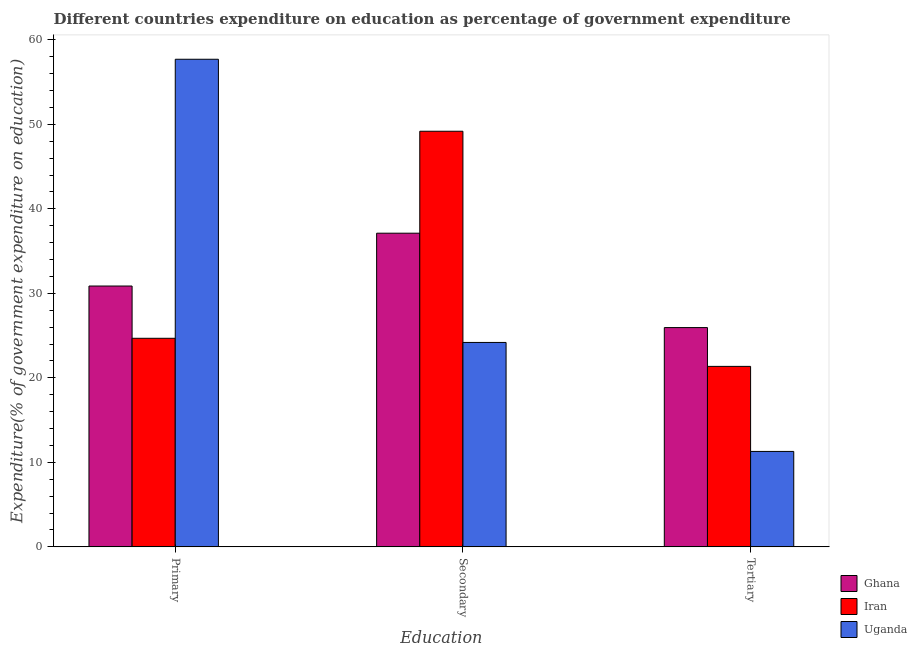How many different coloured bars are there?
Give a very brief answer. 3. How many bars are there on the 1st tick from the left?
Offer a terse response. 3. How many bars are there on the 1st tick from the right?
Your response must be concise. 3. What is the label of the 2nd group of bars from the left?
Make the answer very short. Secondary. What is the expenditure on primary education in Ghana?
Give a very brief answer. 30.87. Across all countries, what is the maximum expenditure on primary education?
Your response must be concise. 57.7. Across all countries, what is the minimum expenditure on tertiary education?
Provide a short and direct response. 11.29. In which country was the expenditure on primary education maximum?
Offer a terse response. Uganda. In which country was the expenditure on secondary education minimum?
Ensure brevity in your answer.  Uganda. What is the total expenditure on secondary education in the graph?
Offer a very short reply. 110.49. What is the difference between the expenditure on primary education in Ghana and that in Iran?
Offer a very short reply. 6.19. What is the difference between the expenditure on secondary education in Iran and the expenditure on tertiary education in Uganda?
Keep it short and to the point. 37.89. What is the average expenditure on primary education per country?
Your answer should be very brief. 37.75. What is the difference between the expenditure on tertiary education and expenditure on secondary education in Uganda?
Ensure brevity in your answer.  -12.9. What is the ratio of the expenditure on tertiary education in Ghana to that in Iran?
Offer a terse response. 1.21. Is the difference between the expenditure on tertiary education in Iran and Ghana greater than the difference between the expenditure on primary education in Iran and Ghana?
Your response must be concise. Yes. What is the difference between the highest and the second highest expenditure on tertiary education?
Provide a short and direct response. 4.59. What is the difference between the highest and the lowest expenditure on secondary education?
Keep it short and to the point. 24.99. In how many countries, is the expenditure on tertiary education greater than the average expenditure on tertiary education taken over all countries?
Keep it short and to the point. 2. Is the sum of the expenditure on primary education in Ghana and Uganda greater than the maximum expenditure on secondary education across all countries?
Your response must be concise. Yes. What does the 2nd bar from the left in Primary represents?
Offer a terse response. Iran. What does the 1st bar from the right in Secondary represents?
Provide a short and direct response. Uganda. Is it the case that in every country, the sum of the expenditure on primary education and expenditure on secondary education is greater than the expenditure on tertiary education?
Your response must be concise. Yes. How many bars are there?
Give a very brief answer. 9. Are all the bars in the graph horizontal?
Offer a very short reply. No. What is the difference between two consecutive major ticks on the Y-axis?
Provide a short and direct response. 10. Does the graph contain any zero values?
Offer a very short reply. No. Does the graph contain grids?
Offer a very short reply. No. How are the legend labels stacked?
Offer a terse response. Vertical. What is the title of the graph?
Provide a short and direct response. Different countries expenditure on education as percentage of government expenditure. Does "Europe(all income levels)" appear as one of the legend labels in the graph?
Ensure brevity in your answer.  No. What is the label or title of the X-axis?
Give a very brief answer. Education. What is the label or title of the Y-axis?
Offer a terse response. Expenditure(% of government expenditure on education). What is the Expenditure(% of government expenditure on education) in Ghana in Primary?
Make the answer very short. 30.87. What is the Expenditure(% of government expenditure on education) in Iran in Primary?
Your answer should be very brief. 24.68. What is the Expenditure(% of government expenditure on education) in Uganda in Primary?
Provide a succinct answer. 57.7. What is the Expenditure(% of government expenditure on education) of Ghana in Secondary?
Offer a terse response. 37.12. What is the Expenditure(% of government expenditure on education) in Iran in Secondary?
Your answer should be compact. 49.18. What is the Expenditure(% of government expenditure on education) of Uganda in Secondary?
Your answer should be very brief. 24.19. What is the Expenditure(% of government expenditure on education) of Ghana in Tertiary?
Offer a very short reply. 25.95. What is the Expenditure(% of government expenditure on education) in Iran in Tertiary?
Ensure brevity in your answer.  21.36. What is the Expenditure(% of government expenditure on education) in Uganda in Tertiary?
Offer a very short reply. 11.29. Across all Education, what is the maximum Expenditure(% of government expenditure on education) of Ghana?
Provide a short and direct response. 37.12. Across all Education, what is the maximum Expenditure(% of government expenditure on education) of Iran?
Provide a succinct answer. 49.18. Across all Education, what is the maximum Expenditure(% of government expenditure on education) of Uganda?
Give a very brief answer. 57.7. Across all Education, what is the minimum Expenditure(% of government expenditure on education) in Ghana?
Offer a terse response. 25.95. Across all Education, what is the minimum Expenditure(% of government expenditure on education) in Iran?
Your answer should be compact. 21.36. Across all Education, what is the minimum Expenditure(% of government expenditure on education) of Uganda?
Make the answer very short. 11.29. What is the total Expenditure(% of government expenditure on education) in Ghana in the graph?
Your answer should be compact. 93.93. What is the total Expenditure(% of government expenditure on education) in Iran in the graph?
Give a very brief answer. 95.22. What is the total Expenditure(% of government expenditure on education) in Uganda in the graph?
Your response must be concise. 93.18. What is the difference between the Expenditure(% of government expenditure on education) of Ghana in Primary and that in Secondary?
Provide a succinct answer. -6.25. What is the difference between the Expenditure(% of government expenditure on education) in Iran in Primary and that in Secondary?
Your response must be concise. -24.5. What is the difference between the Expenditure(% of government expenditure on education) of Uganda in Primary and that in Secondary?
Make the answer very short. 33.51. What is the difference between the Expenditure(% of government expenditure on education) in Ghana in Primary and that in Tertiary?
Your answer should be compact. 4.92. What is the difference between the Expenditure(% of government expenditure on education) of Iran in Primary and that in Tertiary?
Your response must be concise. 3.32. What is the difference between the Expenditure(% of government expenditure on education) of Uganda in Primary and that in Tertiary?
Your response must be concise. 46.41. What is the difference between the Expenditure(% of government expenditure on education) of Ghana in Secondary and that in Tertiary?
Offer a terse response. 11.17. What is the difference between the Expenditure(% of government expenditure on education) in Iran in Secondary and that in Tertiary?
Offer a very short reply. 27.83. What is the difference between the Expenditure(% of government expenditure on education) of Uganda in Secondary and that in Tertiary?
Offer a very short reply. 12.9. What is the difference between the Expenditure(% of government expenditure on education) in Ghana in Primary and the Expenditure(% of government expenditure on education) in Iran in Secondary?
Provide a succinct answer. -18.32. What is the difference between the Expenditure(% of government expenditure on education) in Ghana in Primary and the Expenditure(% of government expenditure on education) in Uganda in Secondary?
Give a very brief answer. 6.68. What is the difference between the Expenditure(% of government expenditure on education) in Iran in Primary and the Expenditure(% of government expenditure on education) in Uganda in Secondary?
Ensure brevity in your answer.  0.49. What is the difference between the Expenditure(% of government expenditure on education) of Ghana in Primary and the Expenditure(% of government expenditure on education) of Iran in Tertiary?
Provide a short and direct response. 9.51. What is the difference between the Expenditure(% of government expenditure on education) in Ghana in Primary and the Expenditure(% of government expenditure on education) in Uganda in Tertiary?
Offer a very short reply. 19.57. What is the difference between the Expenditure(% of government expenditure on education) in Iran in Primary and the Expenditure(% of government expenditure on education) in Uganda in Tertiary?
Offer a terse response. 13.39. What is the difference between the Expenditure(% of government expenditure on education) in Ghana in Secondary and the Expenditure(% of government expenditure on education) in Iran in Tertiary?
Your answer should be very brief. 15.76. What is the difference between the Expenditure(% of government expenditure on education) of Ghana in Secondary and the Expenditure(% of government expenditure on education) of Uganda in Tertiary?
Make the answer very short. 25.82. What is the difference between the Expenditure(% of government expenditure on education) of Iran in Secondary and the Expenditure(% of government expenditure on education) of Uganda in Tertiary?
Keep it short and to the point. 37.89. What is the average Expenditure(% of government expenditure on education) in Ghana per Education?
Provide a short and direct response. 31.31. What is the average Expenditure(% of government expenditure on education) of Iran per Education?
Offer a very short reply. 31.74. What is the average Expenditure(% of government expenditure on education) in Uganda per Education?
Ensure brevity in your answer.  31.06. What is the difference between the Expenditure(% of government expenditure on education) of Ghana and Expenditure(% of government expenditure on education) of Iran in Primary?
Give a very brief answer. 6.19. What is the difference between the Expenditure(% of government expenditure on education) of Ghana and Expenditure(% of government expenditure on education) of Uganda in Primary?
Keep it short and to the point. -26.83. What is the difference between the Expenditure(% of government expenditure on education) of Iran and Expenditure(% of government expenditure on education) of Uganda in Primary?
Ensure brevity in your answer.  -33.02. What is the difference between the Expenditure(% of government expenditure on education) of Ghana and Expenditure(% of government expenditure on education) of Iran in Secondary?
Offer a very short reply. -12.07. What is the difference between the Expenditure(% of government expenditure on education) of Ghana and Expenditure(% of government expenditure on education) of Uganda in Secondary?
Make the answer very short. 12.93. What is the difference between the Expenditure(% of government expenditure on education) in Iran and Expenditure(% of government expenditure on education) in Uganda in Secondary?
Provide a short and direct response. 24.99. What is the difference between the Expenditure(% of government expenditure on education) of Ghana and Expenditure(% of government expenditure on education) of Iran in Tertiary?
Make the answer very short. 4.59. What is the difference between the Expenditure(% of government expenditure on education) of Ghana and Expenditure(% of government expenditure on education) of Uganda in Tertiary?
Make the answer very short. 14.66. What is the difference between the Expenditure(% of government expenditure on education) in Iran and Expenditure(% of government expenditure on education) in Uganda in Tertiary?
Offer a very short reply. 10.06. What is the ratio of the Expenditure(% of government expenditure on education) in Ghana in Primary to that in Secondary?
Your response must be concise. 0.83. What is the ratio of the Expenditure(% of government expenditure on education) in Iran in Primary to that in Secondary?
Your answer should be compact. 0.5. What is the ratio of the Expenditure(% of government expenditure on education) of Uganda in Primary to that in Secondary?
Keep it short and to the point. 2.39. What is the ratio of the Expenditure(% of government expenditure on education) in Ghana in Primary to that in Tertiary?
Your answer should be compact. 1.19. What is the ratio of the Expenditure(% of government expenditure on education) of Iran in Primary to that in Tertiary?
Make the answer very short. 1.16. What is the ratio of the Expenditure(% of government expenditure on education) of Uganda in Primary to that in Tertiary?
Offer a very short reply. 5.11. What is the ratio of the Expenditure(% of government expenditure on education) in Ghana in Secondary to that in Tertiary?
Keep it short and to the point. 1.43. What is the ratio of the Expenditure(% of government expenditure on education) of Iran in Secondary to that in Tertiary?
Keep it short and to the point. 2.3. What is the ratio of the Expenditure(% of government expenditure on education) in Uganda in Secondary to that in Tertiary?
Your response must be concise. 2.14. What is the difference between the highest and the second highest Expenditure(% of government expenditure on education) of Ghana?
Give a very brief answer. 6.25. What is the difference between the highest and the second highest Expenditure(% of government expenditure on education) of Iran?
Your response must be concise. 24.5. What is the difference between the highest and the second highest Expenditure(% of government expenditure on education) of Uganda?
Provide a succinct answer. 33.51. What is the difference between the highest and the lowest Expenditure(% of government expenditure on education) of Ghana?
Your answer should be very brief. 11.17. What is the difference between the highest and the lowest Expenditure(% of government expenditure on education) of Iran?
Provide a succinct answer. 27.83. What is the difference between the highest and the lowest Expenditure(% of government expenditure on education) of Uganda?
Give a very brief answer. 46.41. 